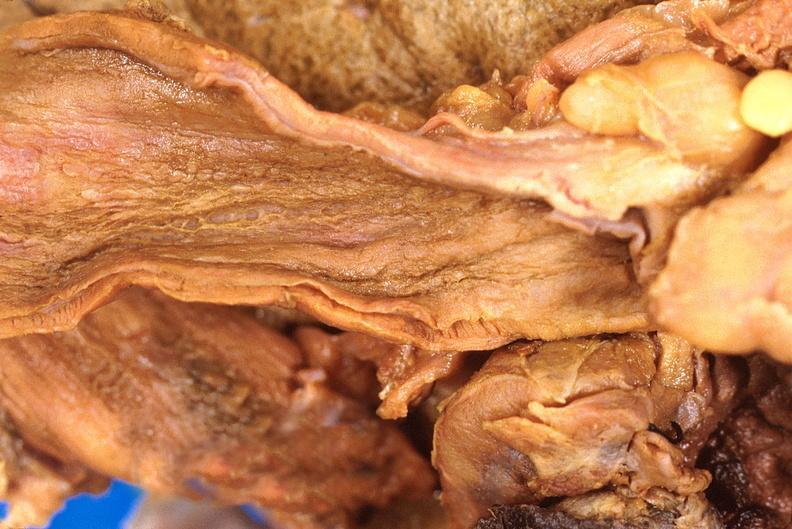where does this belong to?
Answer the question using a single word or phrase. Gastrointestinal system 